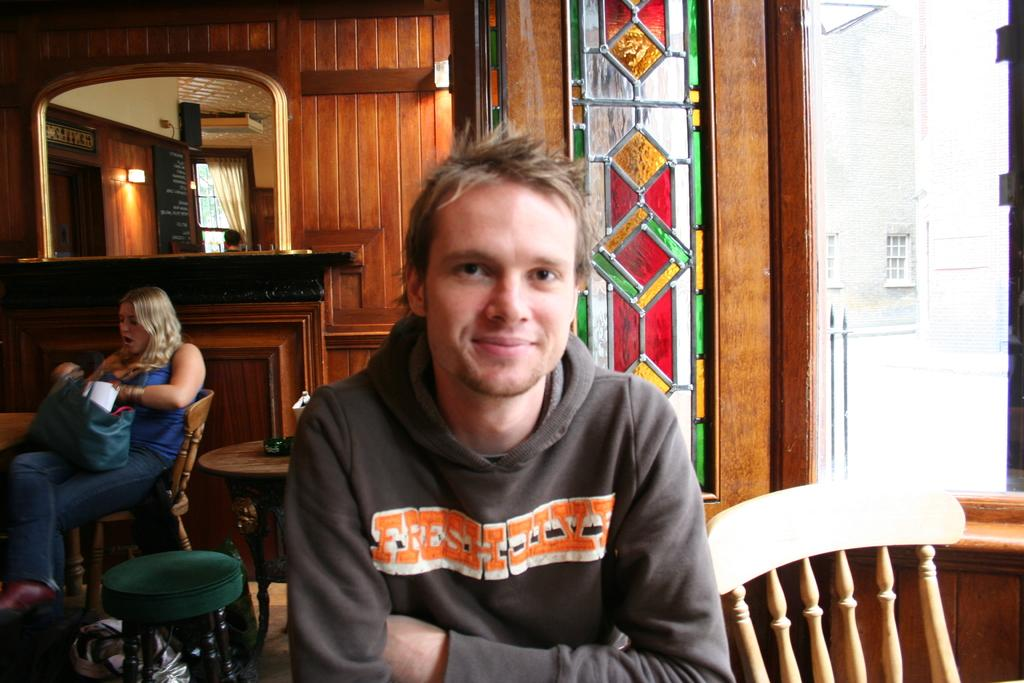How many people are sitting in the image? There are two persons sitting on chairs in the image. What is one person holding? One person is holding a bag. What can be seen in the background of the image? There is a glass window and a mirror in the background. What type of furniture is visible in the image? Chairs are visible in the image. What is visible through the glass window? A wall is visible through the glass window. What type of planes can be seen flying outside the glass window? There are no planes visible in the image; only a wall can be seen through the glass window. How many sheep are present in the image? There are no sheep present in the image. 